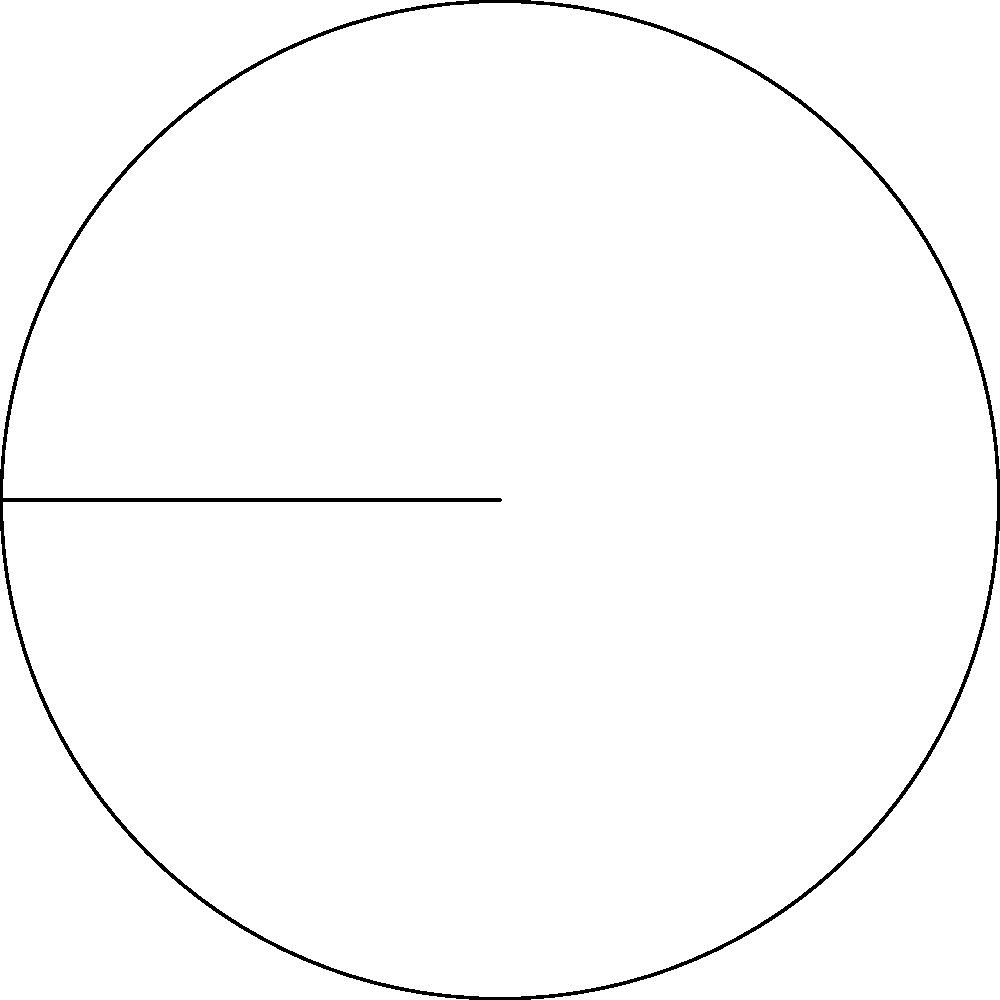In the spirit of harmony and interconnectedness, consider a circle with radius $r = 3$ units. An inscribed angle of $60°$ is formed at the center O, creating an arc AB. What is the length of arc AB? Let's approach this step-by-step, mindful of the interconnectedness of mathematical concepts:

1) First, recall the relationship between inscribed angles and central angles:
   A central angle is twice the inscribed angle that subtends the same arc.

2) In this case, the inscribed angle is $60°$, so the central angle would be:
   Central angle = $2 \times 60° = 120°$

3) Now, we can use the formula for arc length:
   Arc length = $\frac{\theta}{360°} \times 2\pi r$
   Where $\theta$ is the central angle in degrees, and $r$ is the radius.

4) Substituting our values:
   Arc length = $\frac{120°}{360°} \times 2\pi \times 3$

5) Simplify:
   Arc length = $\frac{1}{3} \times 2\pi \times 3 = 2\pi$ units

Thus, we find that the arc length is equal to $2\pi$ units, representing a full third of the circle's circumference. This balance and proportion reflect the harmony we often seek in our understanding of the world.
Answer: $2\pi$ units 